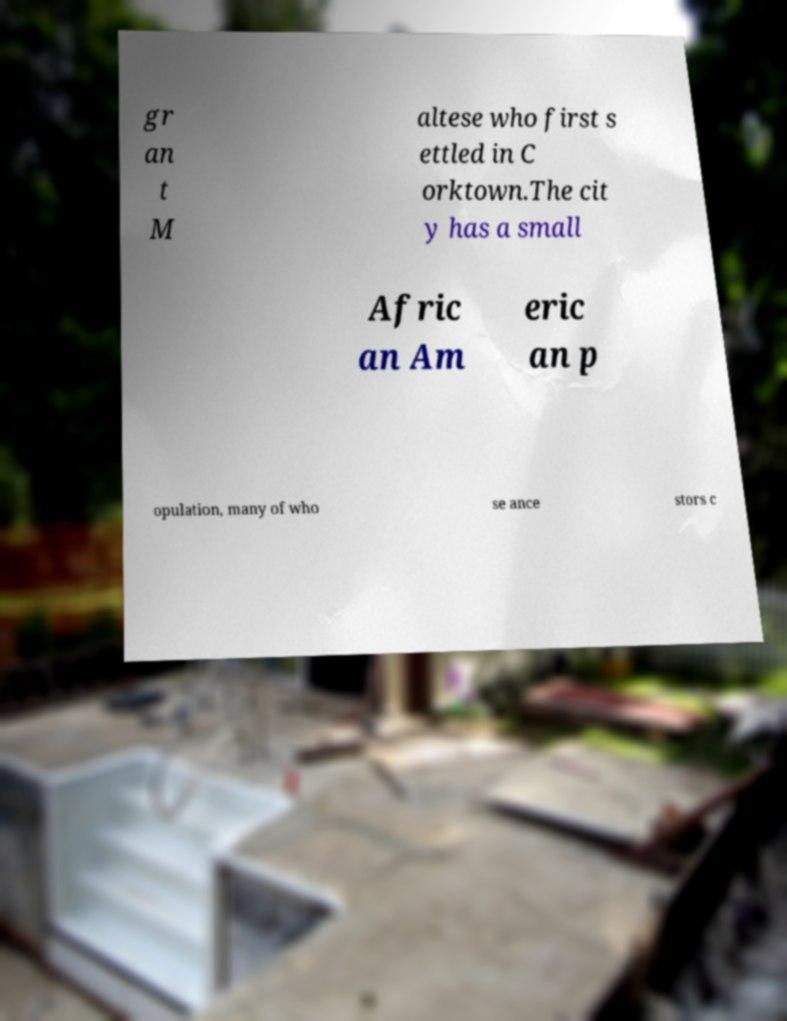What messages or text are displayed in this image? I need them in a readable, typed format. gr an t M altese who first s ettled in C orktown.The cit y has a small Afric an Am eric an p opulation, many of who se ance stors c 